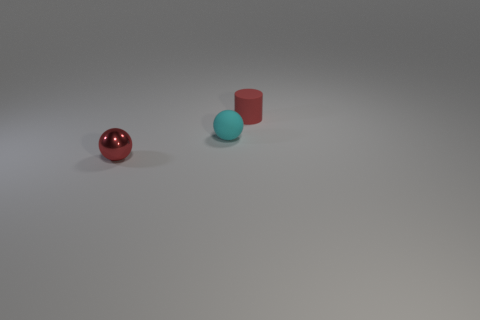Add 3 brown objects. How many objects exist? 6 Subtract all balls. How many objects are left? 1 Subtract 0 yellow cubes. How many objects are left? 3 Subtract all tiny cyan matte spheres. Subtract all large metal cubes. How many objects are left? 2 Add 3 tiny red spheres. How many tiny red spheres are left? 4 Add 2 tiny cyan objects. How many tiny cyan objects exist? 3 